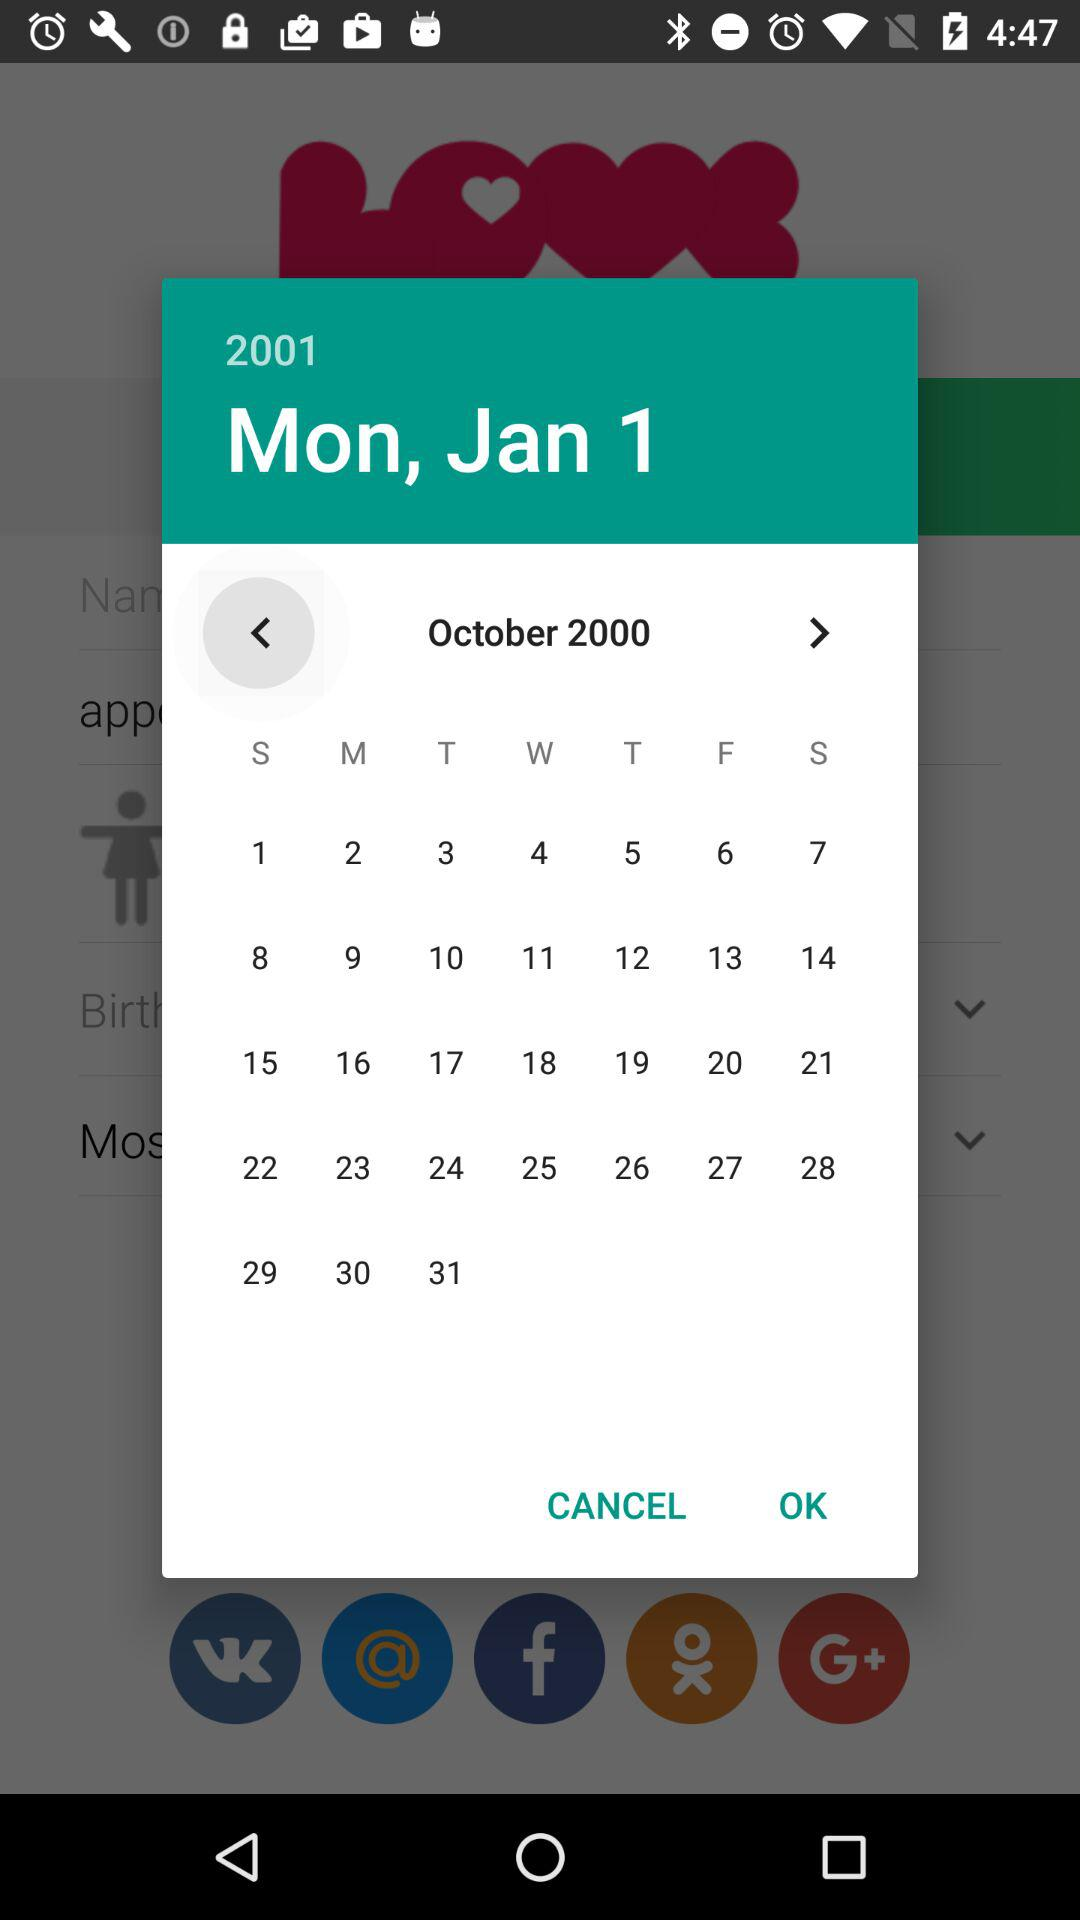Which gender is selected?
When the provided information is insufficient, respond with <no answer>. <no answer> 